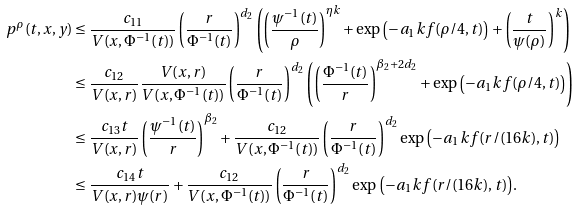<formula> <loc_0><loc_0><loc_500><loc_500>p ^ { \rho } ( t , x , y ) & \leq \frac { c _ { 1 1 } } { V ( x , \Phi ^ { - 1 } ( t ) ) } \left ( \frac { r } { \Phi ^ { - 1 } ( t ) } \right ) ^ { d _ { 2 } } \left ( \left ( \frac { \psi ^ { - 1 } ( t ) } { \rho } \right ) ^ { \eta k } + \exp { \left ( - a _ { 1 } k f ( \rho / 4 , t ) \right ) } + \left ( \frac { t } { \psi ( \rho ) } \right ) ^ { k } \right ) \\ & \leq \frac { c _ { 1 2 } } { V ( x , r ) } \frac { V ( x , r ) } { V ( x , \Phi ^ { - 1 } ( t ) ) } \left ( \frac { r } { \Phi ^ { - 1 } ( t ) } \right ) ^ { d _ { 2 } } \left ( \left ( \frac { \Phi ^ { - 1 } ( t ) } { r } \right ) ^ { \beta _ { 2 } + 2 d _ { 2 } } + \exp { \left ( - a _ { 1 } k f ( \rho / 4 , t ) \right ) } \right ) \\ & \leq \frac { c _ { 1 3 } t } { V ( x , r ) } \left ( \frac { \psi ^ { - 1 } ( t ) } { r } \right ) ^ { \beta _ { 2 } } + \frac { c _ { 1 2 } } { V ( x , \Phi ^ { - 1 } ( t ) ) } \left ( \frac { r } { \Phi ^ { - 1 } ( t ) } \right ) ^ { d _ { 2 } } \exp { \left ( - a _ { 1 } k f ( r / ( 1 6 k ) , t ) \right ) } \\ & \leq \frac { c _ { 1 4 } t } { V ( x , r ) \psi ( r ) } + \frac { c _ { 1 2 } } { V ( x , \Phi ^ { - 1 } ( t ) ) } \left ( \frac { r } { \Phi ^ { - 1 } ( t ) } \right ) ^ { d _ { 2 } } \exp { \left ( - a _ { 1 } k f ( r / ( 1 6 k ) , t ) \right ) } .</formula> 